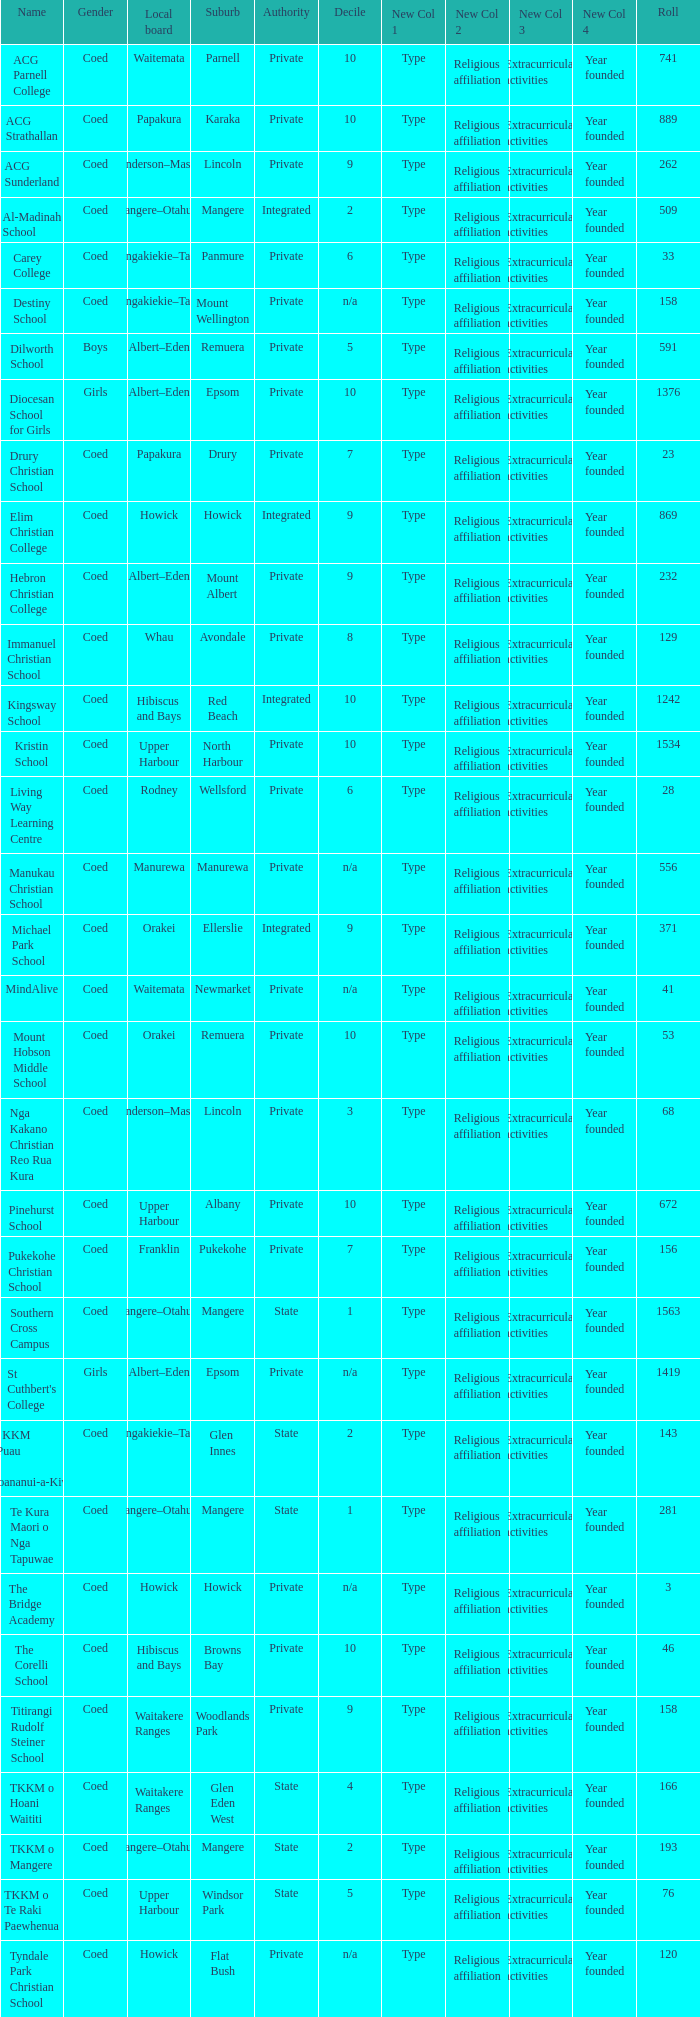What is the name of the suburb with a roll of 741? Parnell. 